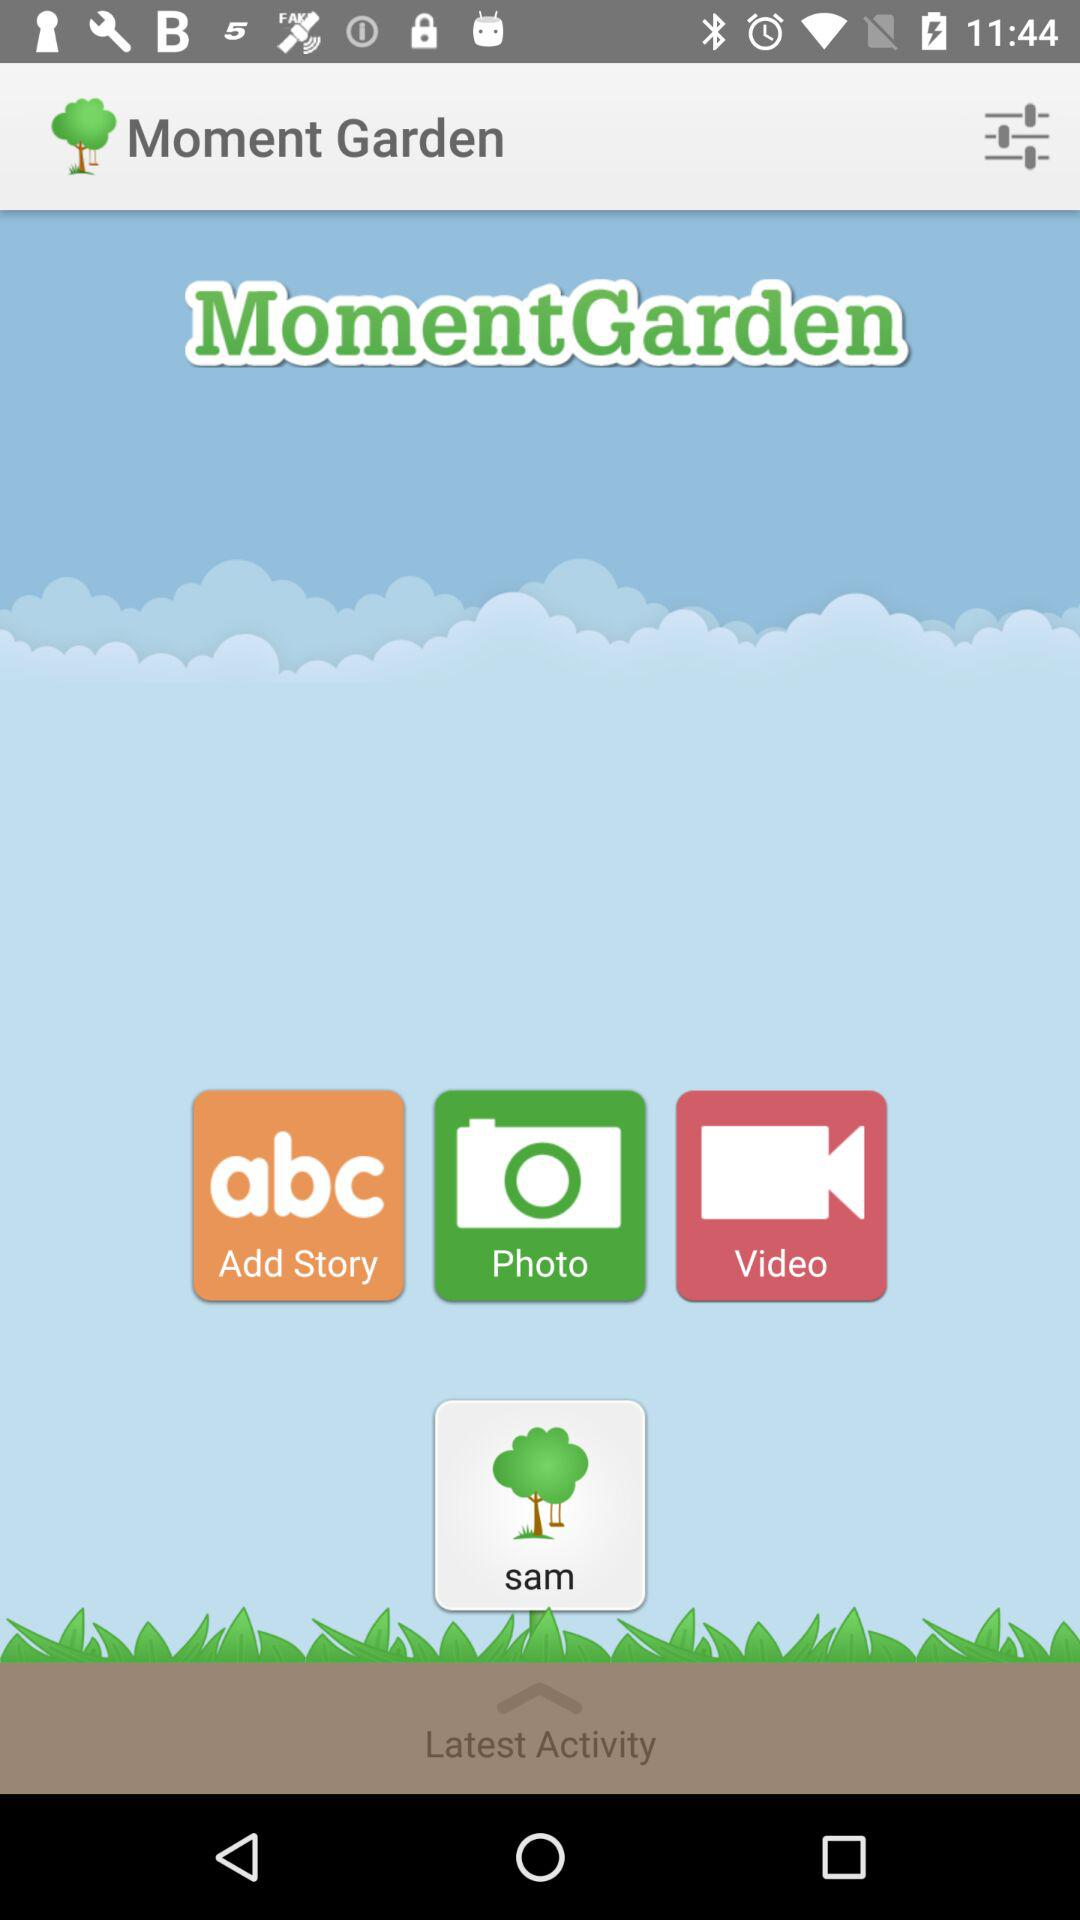What is the name of the application? The name of the application is "Moment Garden". 